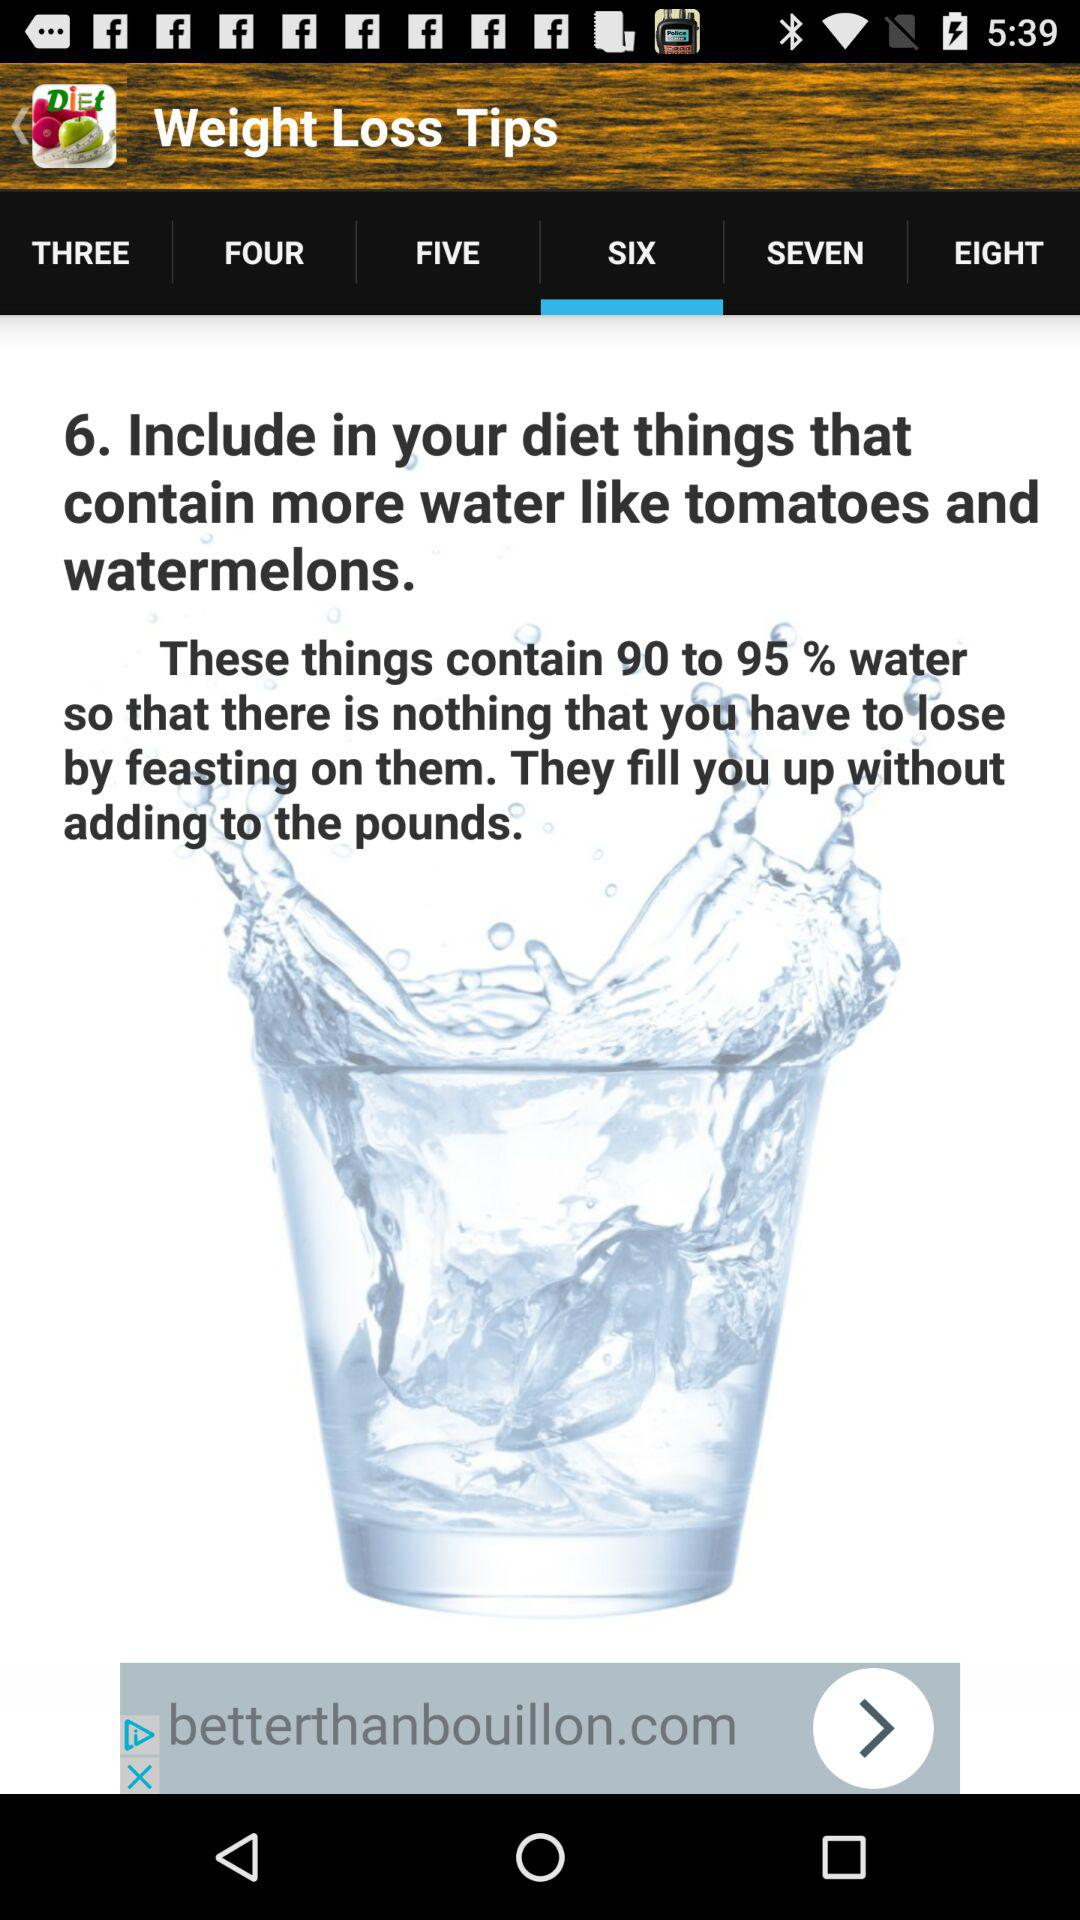What tab is selected? The selected tab is "SIX". 